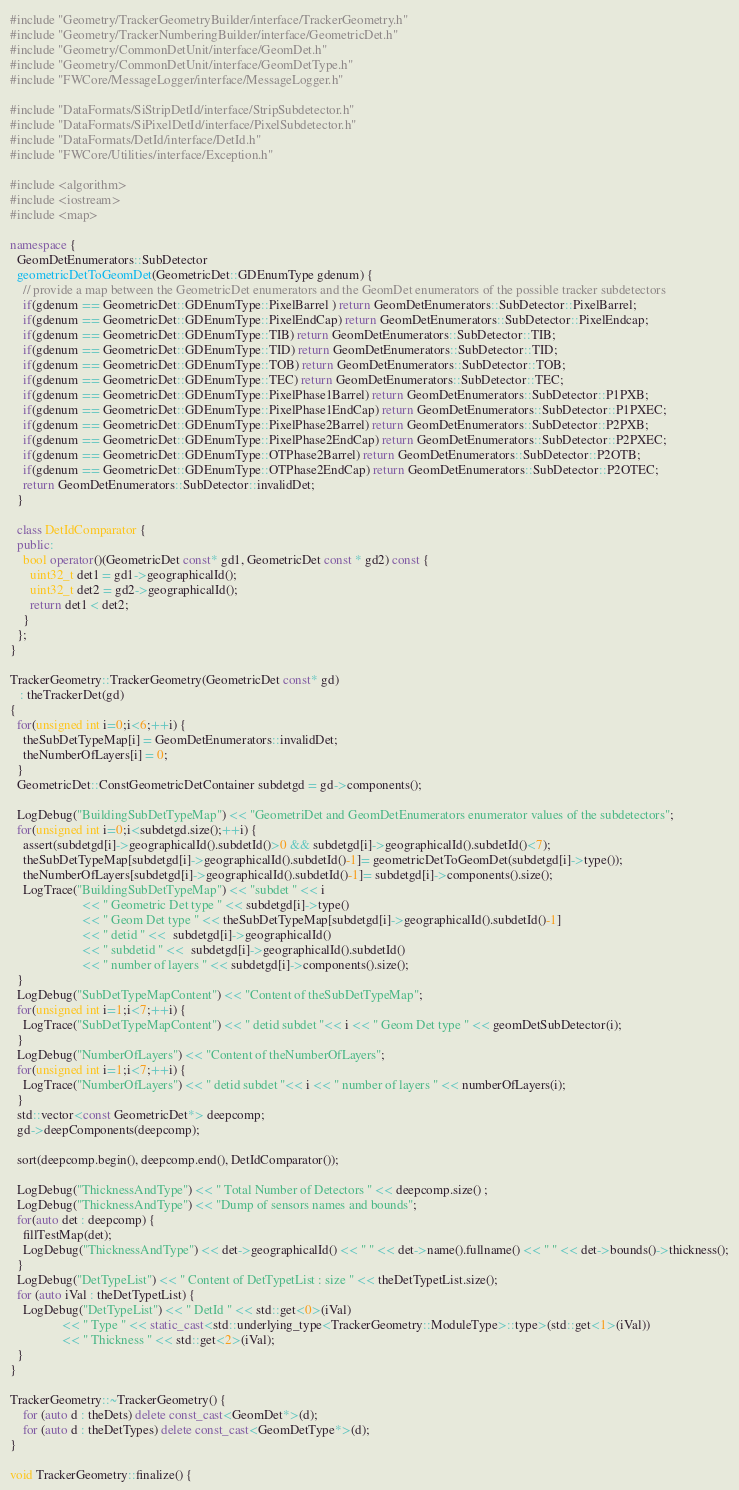Convert code to text. <code><loc_0><loc_0><loc_500><loc_500><_C++_>#include "Geometry/TrackerGeometryBuilder/interface/TrackerGeometry.h"
#include "Geometry/TrackerNumberingBuilder/interface/GeometricDet.h"
#include "Geometry/CommonDetUnit/interface/GeomDet.h"
#include "Geometry/CommonDetUnit/interface/GeomDetType.h"
#include "FWCore/MessageLogger/interface/MessageLogger.h"

#include "DataFormats/SiStripDetId/interface/StripSubdetector.h"
#include "DataFormats/SiPixelDetId/interface/PixelSubdetector.h"
#include "DataFormats/DetId/interface/DetId.h"
#include "FWCore/Utilities/interface/Exception.h"

#include <algorithm>
#include <iostream>
#include <map>

namespace {
  GeomDetEnumerators::SubDetector
  geometricDetToGeomDet(GeometricDet::GDEnumType gdenum) {
    // provide a map between the GeometricDet enumerators and the GeomDet enumerators of the possible tracker subdetectors
    if(gdenum == GeometricDet::GDEnumType::PixelBarrel ) return GeomDetEnumerators::SubDetector::PixelBarrel;
    if(gdenum == GeometricDet::GDEnumType::PixelEndCap) return GeomDetEnumerators::SubDetector::PixelEndcap;
    if(gdenum == GeometricDet::GDEnumType::TIB) return GeomDetEnumerators::SubDetector::TIB;
    if(gdenum == GeometricDet::GDEnumType::TID) return GeomDetEnumerators::SubDetector::TID;
    if(gdenum == GeometricDet::GDEnumType::TOB) return GeomDetEnumerators::SubDetector::TOB;
    if(gdenum == GeometricDet::GDEnumType::TEC) return GeomDetEnumerators::SubDetector::TEC;
    if(gdenum == GeometricDet::GDEnumType::PixelPhase1Barrel) return GeomDetEnumerators::SubDetector::P1PXB;
    if(gdenum == GeometricDet::GDEnumType::PixelPhase1EndCap) return GeomDetEnumerators::SubDetector::P1PXEC;
    if(gdenum == GeometricDet::GDEnumType::PixelPhase2Barrel) return GeomDetEnumerators::SubDetector::P2PXB;
    if(gdenum == GeometricDet::GDEnumType::PixelPhase2EndCap) return GeomDetEnumerators::SubDetector::P2PXEC;
    if(gdenum == GeometricDet::GDEnumType::OTPhase2Barrel) return GeomDetEnumerators::SubDetector::P2OTB;
    if(gdenum == GeometricDet::GDEnumType::OTPhase2EndCap) return GeomDetEnumerators::SubDetector::P2OTEC;
    return GeomDetEnumerators::SubDetector::invalidDet;
  }
  
  class DetIdComparator {
  public:
    bool operator()(GeometricDet const* gd1, GeometricDet const * gd2) const {
      uint32_t det1 = gd1->geographicalId();
      uint32_t det2 = gd2->geographicalId();
      return det1 < det2;
    }  
  };
}

TrackerGeometry::TrackerGeometry(GeometricDet const* gd)
   : theTrackerDet(gd)
{
  for(unsigned int i=0;i<6;++i) {
    theSubDetTypeMap[i] = GeomDetEnumerators::invalidDet;
    theNumberOfLayers[i] = 0;
  }
  GeometricDet::ConstGeometricDetContainer subdetgd = gd->components();
  
  LogDebug("BuildingSubDetTypeMap") << "GeometriDet and GeomDetEnumerators enumerator values of the subdetectors";
  for(unsigned int i=0;i<subdetgd.size();++i) {
    assert(subdetgd[i]->geographicalId().subdetId()>0 && subdetgd[i]->geographicalId().subdetId()<7);
    theSubDetTypeMap[subdetgd[i]->geographicalId().subdetId()-1]= geometricDetToGeomDet(subdetgd[i]->type());
    theNumberOfLayers[subdetgd[i]->geographicalId().subdetId()-1]= subdetgd[i]->components().size();
    LogTrace("BuildingSubDetTypeMap") << "subdet " << i 
				      << " Geometric Det type " << subdetgd[i]->type()
				      << " Geom Det type " << theSubDetTypeMap[subdetgd[i]->geographicalId().subdetId()-1]
				      << " detid " <<  subdetgd[i]->geographicalId()
				      << " subdetid " <<  subdetgd[i]->geographicalId().subdetId()
				      << " number of layers " << subdetgd[i]->components().size();
  }
  LogDebug("SubDetTypeMapContent") << "Content of theSubDetTypeMap";
  for(unsigned int i=1;i<7;++i) {
    LogTrace("SubDetTypeMapContent") << " detid subdet "<< i << " Geom Det type " << geomDetSubDetector(i); 
  }
  LogDebug("NumberOfLayers") << "Content of theNumberOfLayers";
  for(unsigned int i=1;i<7;++i) {
    LogTrace("NumberOfLayers") << " detid subdet "<< i << " number of layers " << numberOfLayers(i); 
  }
  std::vector<const GeometricDet*> deepcomp;
  gd->deepComponents(deepcomp);
   
  sort(deepcomp.begin(), deepcomp.end(), DetIdComparator());

  LogDebug("ThicknessAndType") << " Total Number of Detectors " << deepcomp.size() ;
  LogDebug("ThicknessAndType") << "Dump of sensors names and bounds";
  for(auto det : deepcomp) {
    fillTestMap(det); 
    LogDebug("ThicknessAndType") << det->geographicalId() << " " << det->name().fullname() << " " << det->bounds()->thickness();
  }
  LogDebug("DetTypeList") << " Content of DetTypetList : size " << theDetTypetList.size();
  for (auto iVal : theDetTypetList) {
    LogDebug("DetTypeList") << " DetId " << std::get<0>(iVal)
			    << " Type " << static_cast<std::underlying_type<TrackerGeometry::ModuleType>::type>(std::get<1>(iVal))
			    << " Thickness " << std::get<2>(iVal);
  }  
}

TrackerGeometry::~TrackerGeometry() {
    for (auto d : theDets) delete const_cast<GeomDet*>(d);
    for (auto d : theDetTypes) delete const_cast<GeomDetType*>(d);
}

void TrackerGeometry::finalize() {</code> 